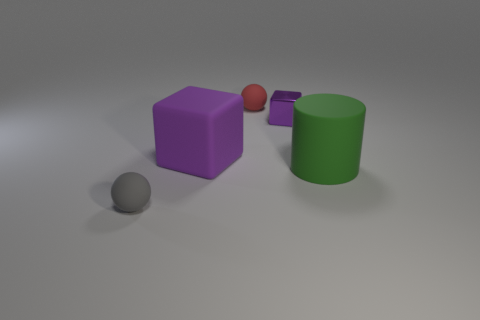There is a small purple object on the right side of the small gray thing; are there any big purple blocks behind it?
Your response must be concise. No. There is a rubber cylinder; are there any rubber spheres in front of it?
Provide a short and direct response. Yes. There is a tiny matte object that is behind the tiny purple cube; does it have the same shape as the gray object?
Provide a succinct answer. Yes. How many large cyan matte things have the same shape as the purple matte object?
Provide a short and direct response. 0. Are there any small red spheres made of the same material as the cylinder?
Make the answer very short. Yes. What is the material of the ball left of the sphere behind the big purple matte object?
Your answer should be very brief. Rubber. What size is the rubber sphere behind the purple shiny thing?
Offer a very short reply. Small. Is the color of the shiny thing the same as the large matte thing that is behind the green rubber cylinder?
Your response must be concise. Yes. Is there a object that has the same color as the matte cube?
Offer a very short reply. Yes. Is the small purple object made of the same material as the object that is on the right side of the tiny metallic block?
Offer a terse response. No. 